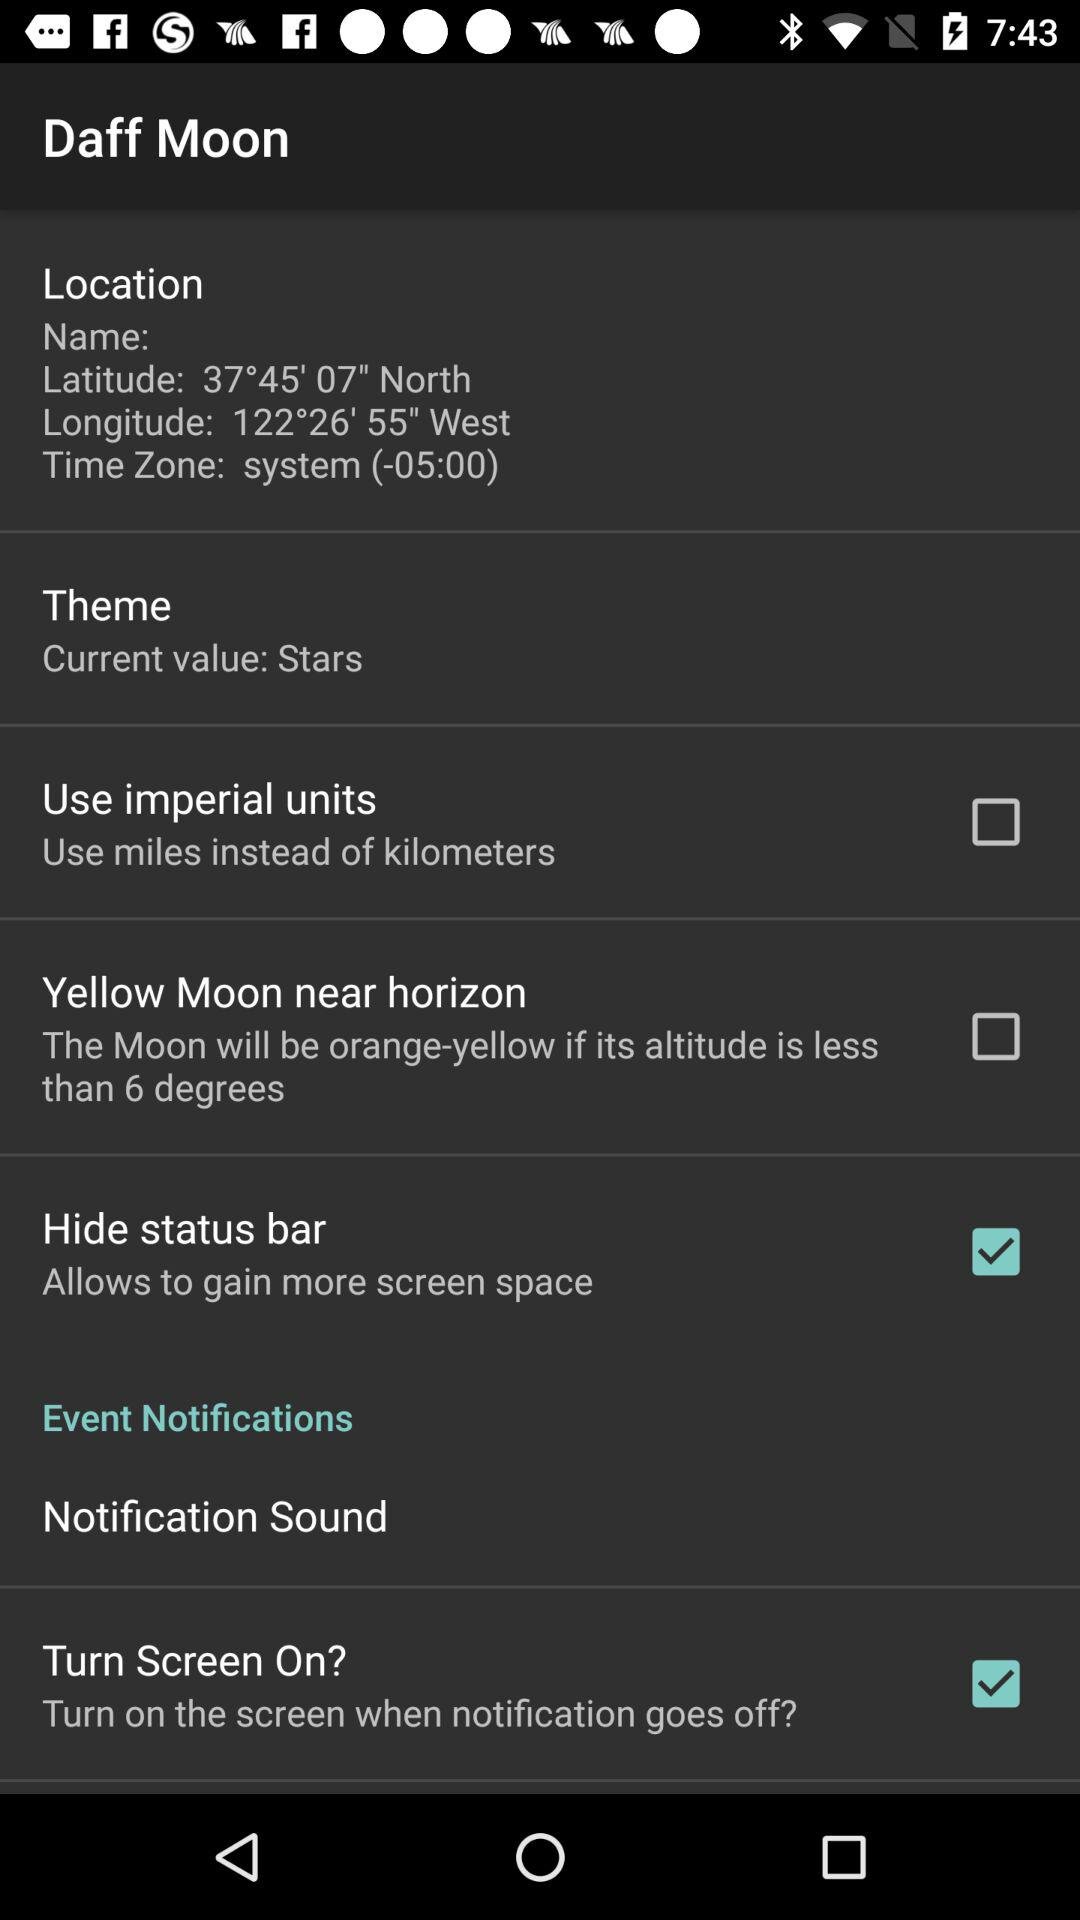What is the status of "Turn Screen On"? The status is "on". 